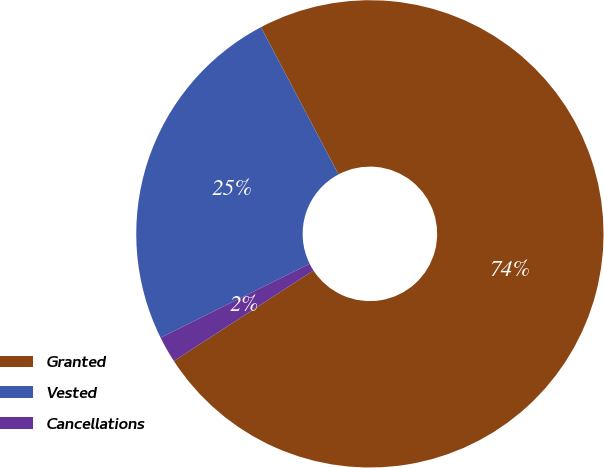Convert chart to OTSL. <chart><loc_0><loc_0><loc_500><loc_500><pie_chart><fcel>Granted<fcel>Vested<fcel>Cancellations<nl><fcel>73.56%<fcel>24.61%<fcel>1.83%<nl></chart> 